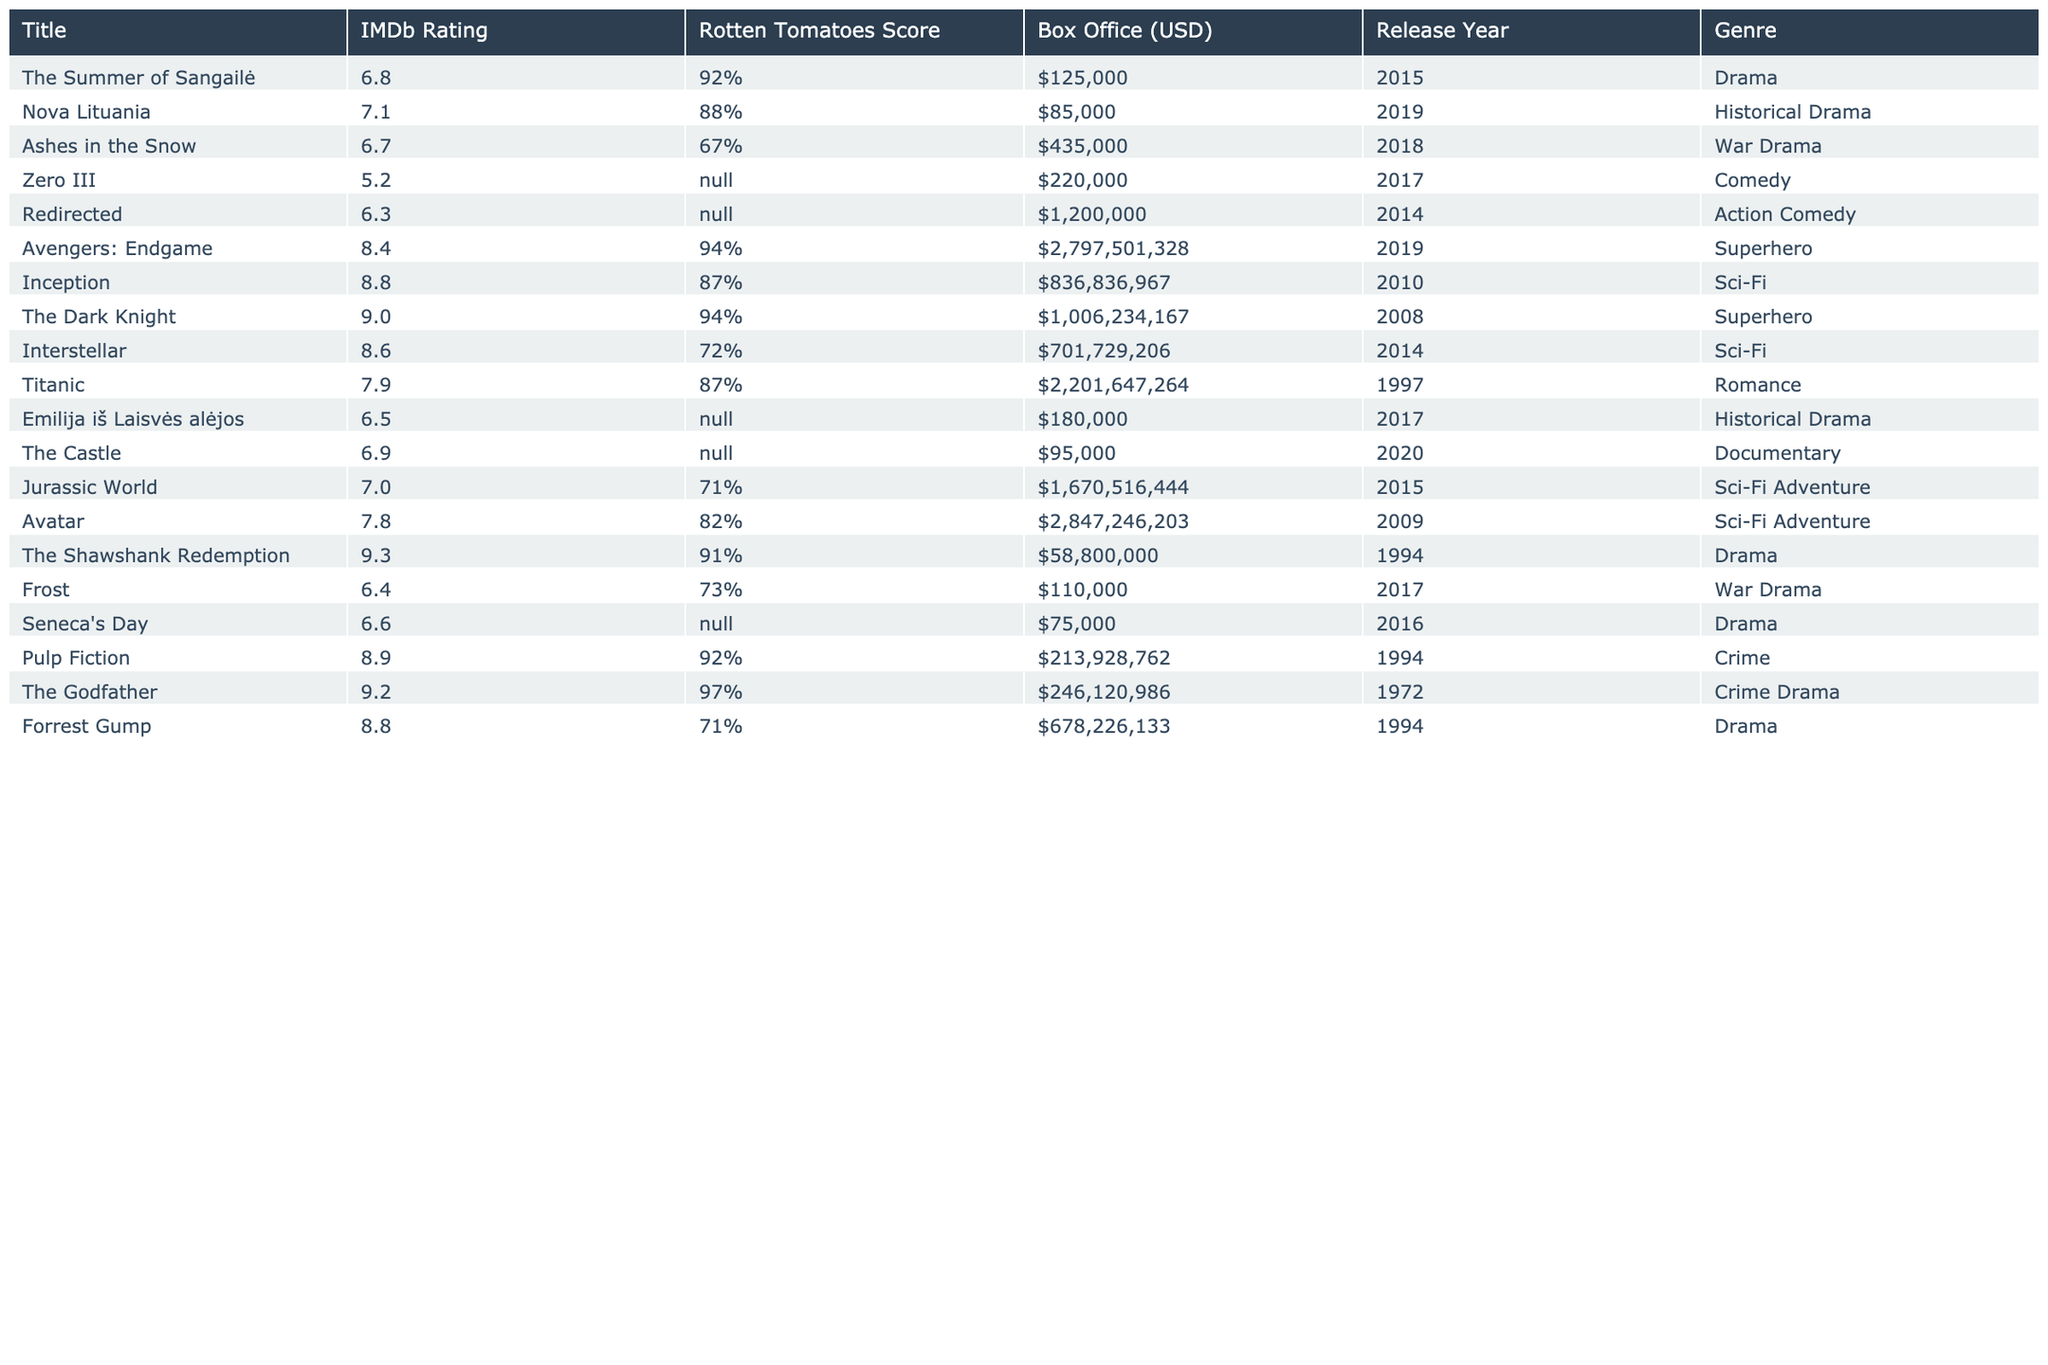What is the IMDb rating of "The Summer of Sangailė"? The IMDb rating for "The Summer of Sangailė" is listed in the table under the IMDb Rating column, which shows a rating of 6.8.
Answer: 6.8 Which film has the highest Rotten Tomatoes score among Lithuanian films? In the table, the Rotten Tomatoes scores for Lithuanian films are listed, with "The Summer of Sangailė" having the highest score at 92%.
Answer: The Summer of Sangailė What is the box office gross of "Pulp Fiction"? Looking at the table, the box office gross for "Pulp Fiction" is listed in the Box Office column as $213,928,762.
Answer: $213,928,762 How many of the Lithuanian films have a Rotten Tomatoes score? Among the Lithuanian films listed, only "The Summer of Sangailė," "Nova Lituania," and "Ashes in the Snow" have Rotten Tomatoes scores. This totals 3 films with scores.
Answer: 3 What is the difference in IMDb ratings between the highest-rated Hollywood film and the highest-rated Lithuanian film? According to the table, the highest-rated Hollywood film is "The Shawshank Redemption" with 9.3, and the highest Lithuanian film is "Nova Lituania" with 7.1. The difference is calculated as 9.3 - 7.1 = 2.2.
Answer: 2.2 Which genre is most represented among the top 10 Hollywood films? By analyzing the genres of the Hollywood films, there are multiple superhero films (3) and several others from different genres. However, superheroes have the most films represented.
Answer: Superhero Is "Interstellar" the film with the lowest box office gross among the Hollywood films? In the table, the box office for "Interstellar" is $701,729,206. Comparing it with other films, it is not the lowest; "The Shawshank Redemption" has a lower box office at $58,800,000. Therefore, the statement is false.
Answer: No What is the average box office gross of the top 10 Lithuanian films? To find the average, first sum the box office grosses: $125,000 + $85,000 + $435,000 + $220,000 + $1,200,000 + $180,000 + $95,000 + $110,000 + $75,000 = $2,555,000. There are 10 films, so the average is $2,555,000 / 10 = $255,500.
Answer: $255,500 Which Hollywood film has a Rotten Tomatoes score closest to "The Summer of Sangailė"? The Rotten Tomatoes score for "The Summer of Sangailė" is 92%. Among Hollywood films, "The Dark Knight" and "Pulp Fiction" both have scores of 94%, which is the closest available score, but none are lower than 92%. Hence, both are close but slightly higher.
Answer: 94% Count how many films have IMDb ratings above 8.0. From the table, the films with IMDb ratings above 8.0 are "Avengers: Endgame" (8.4), "Inception" (8.8), "The Dark Knight" (9.0), "Interstellar" (8.6), "Titanic" (7.9), "The Shawshank Redemption" (9.3), "Pulp Fiction" (8.9), and "Forrest Gump" (8.8). This counts to 8 films.
Answer: 8 What is the Rotten Tomatoes score of "Jurassic World"? The table indicates that "Jurassic World" has a Rotten Tomatoes score of 71%. This is clearly stated under the Rotten Tomatoes Score column in the table.
Answer: 71% 